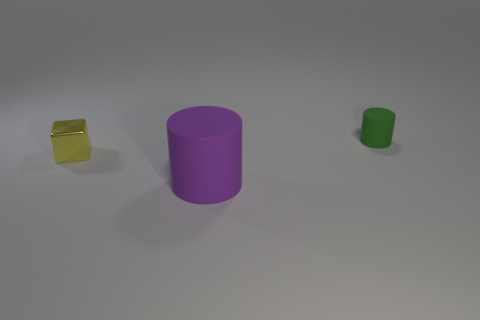Is there any other thing that is the same size as the purple matte cylinder?
Provide a short and direct response. No. There is another large thing that is the same material as the green object; what is its shape?
Your answer should be compact. Cylinder. How many green objects have the same shape as the purple matte object?
Offer a very short reply. 1. Is the shape of the matte object in front of the small rubber cylinder the same as the matte thing that is on the right side of the large purple cylinder?
Provide a succinct answer. Yes. How many objects are big cylinders or tiny matte cylinders on the right side of the small shiny object?
Offer a very short reply. 2. What number of other things are the same size as the green thing?
Make the answer very short. 1. How many red objects are matte cylinders or cubes?
Provide a succinct answer. 0. There is a tiny green thing that is behind the tiny yellow metallic cube behind the large purple matte thing; what is its shape?
Offer a terse response. Cylinder. The green rubber object that is the same size as the yellow cube is what shape?
Give a very brief answer. Cylinder. Is there another rubber cylinder that has the same color as the big rubber cylinder?
Keep it short and to the point. No. 